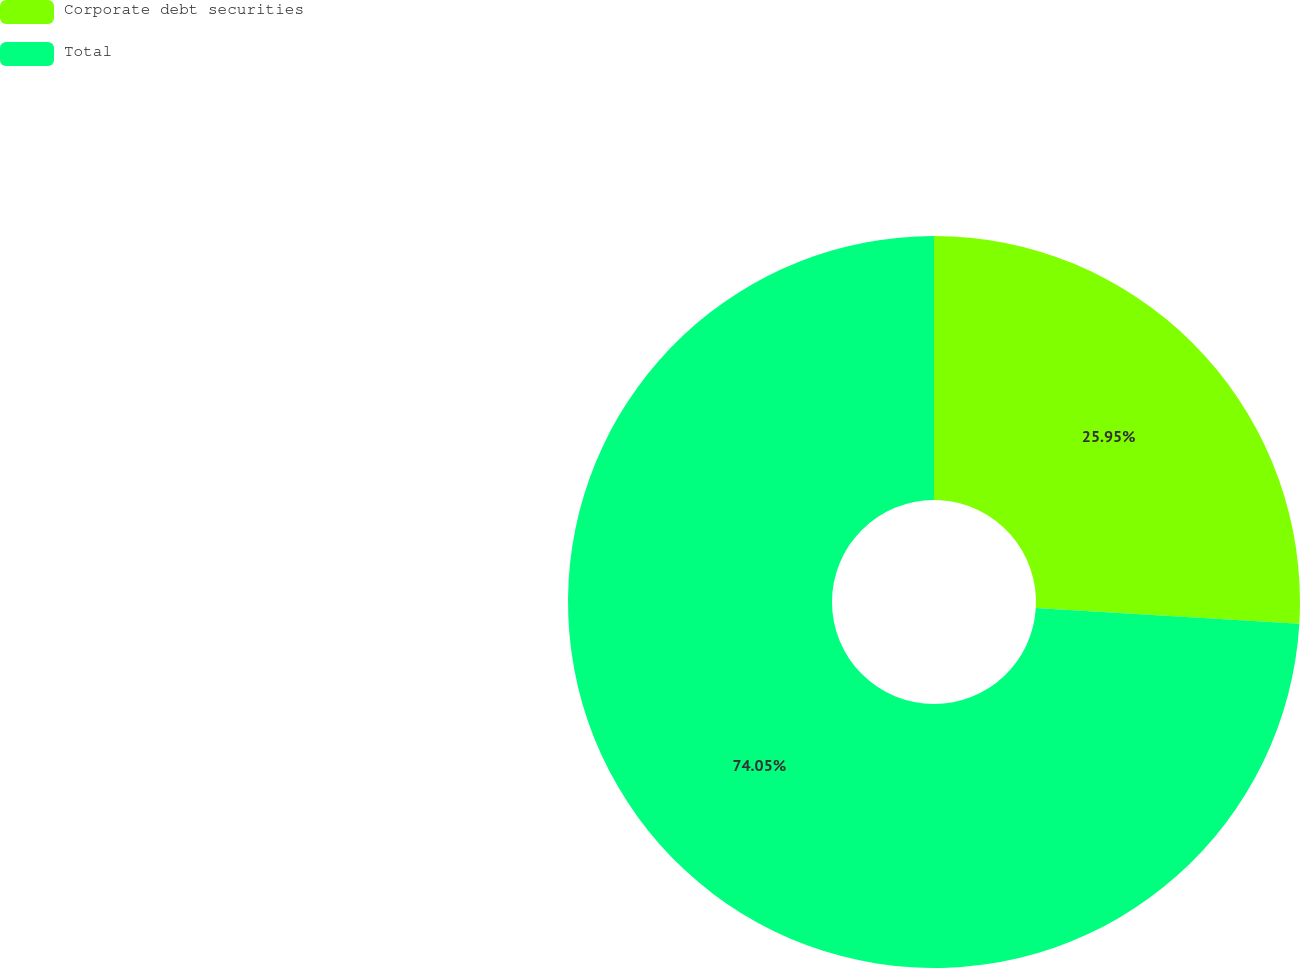<chart> <loc_0><loc_0><loc_500><loc_500><pie_chart><fcel>Corporate debt securities<fcel>Total<nl><fcel>25.95%<fcel>74.05%<nl></chart> 